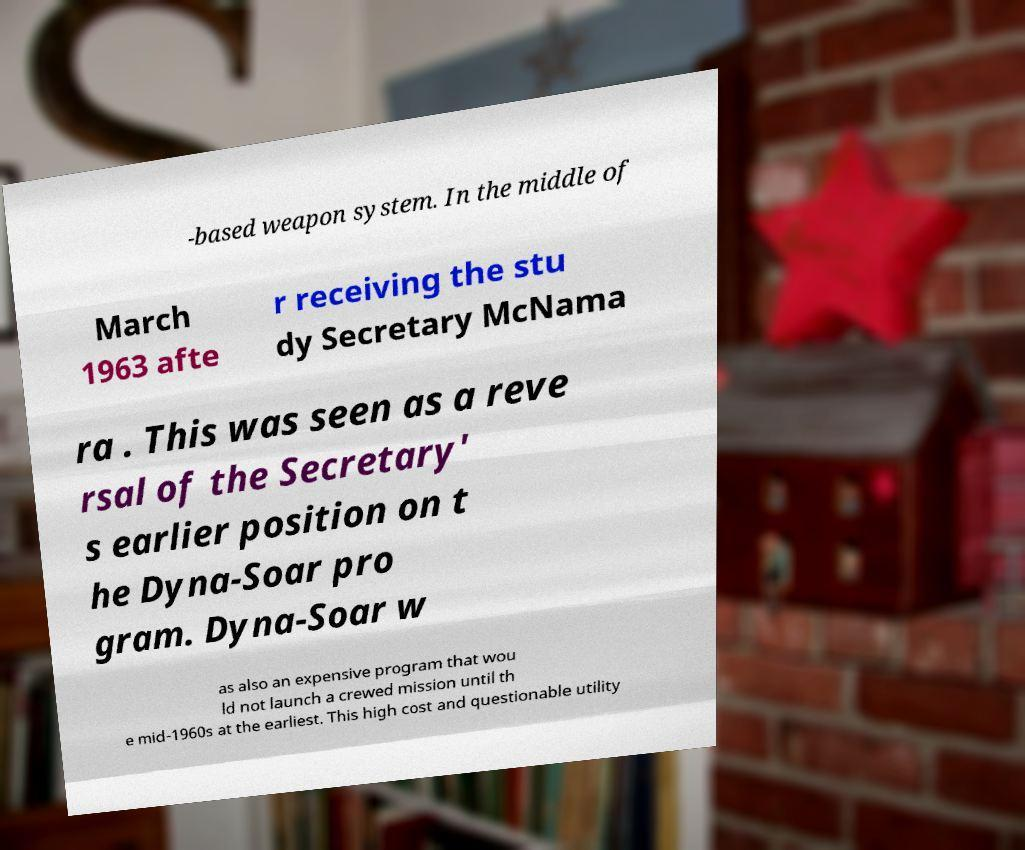What messages or text are displayed in this image? I need them in a readable, typed format. -based weapon system. In the middle of March 1963 afte r receiving the stu dy Secretary McNama ra . This was seen as a reve rsal of the Secretary' s earlier position on t he Dyna-Soar pro gram. Dyna-Soar w as also an expensive program that wou ld not launch a crewed mission until th e mid-1960s at the earliest. This high cost and questionable utility 